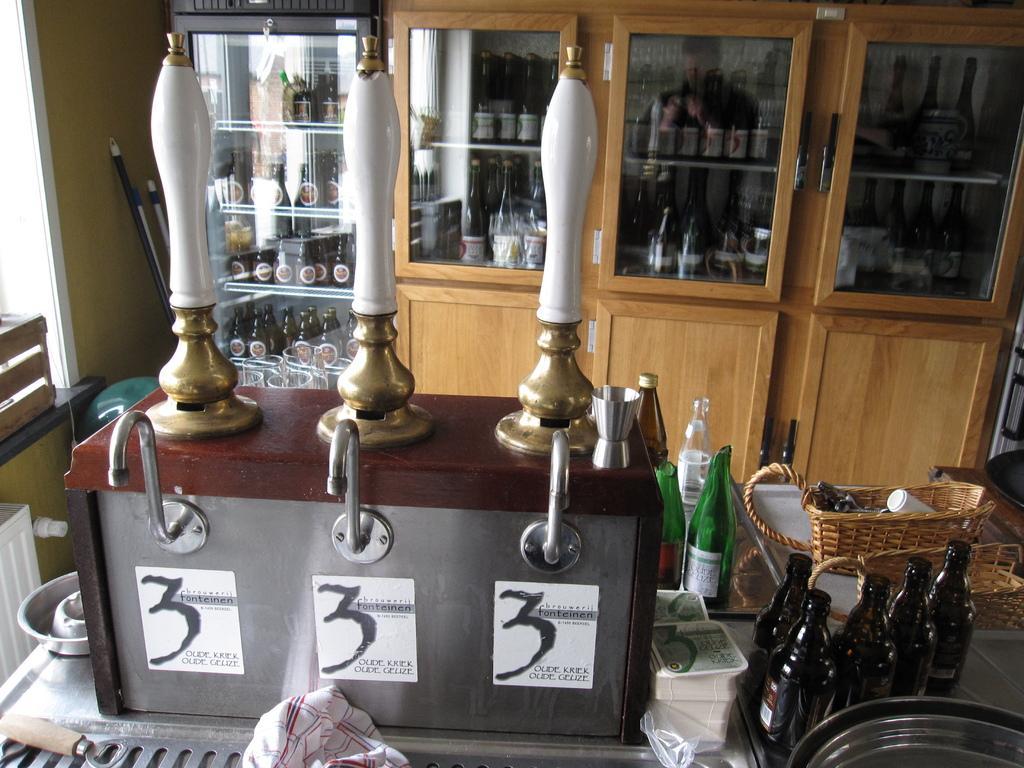Can you describe this image briefly? In this picture there are many bottles which are placed in the cupboard. There are some other bottles which are placed in the refrigerator. To the right , there are group of bottles which are placed on the table. There is a basket on the table. There is a cloth and there are boxes on the table. 